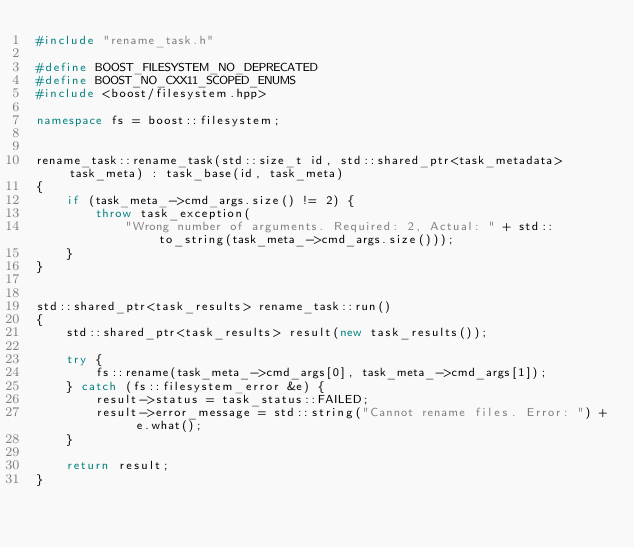Convert code to text. <code><loc_0><loc_0><loc_500><loc_500><_C++_>#include "rename_task.h"

#define BOOST_FILESYSTEM_NO_DEPRECATED
#define BOOST_NO_CXX11_SCOPED_ENUMS
#include <boost/filesystem.hpp>

namespace fs = boost::filesystem;


rename_task::rename_task(std::size_t id, std::shared_ptr<task_metadata> task_meta) : task_base(id, task_meta)
{
	if (task_meta_->cmd_args.size() != 2) {
		throw task_exception(
			"Wrong number of arguments. Required: 2, Actual: " + std::to_string(task_meta_->cmd_args.size()));
	}
}


std::shared_ptr<task_results> rename_task::run()
{
	std::shared_ptr<task_results> result(new task_results());

	try {
		fs::rename(task_meta_->cmd_args[0], task_meta_->cmd_args[1]);
	} catch (fs::filesystem_error &e) {
		result->status = task_status::FAILED;
		result->error_message = std::string("Cannot rename files. Error: ") + e.what();
	}

	return result;
}
</code> 